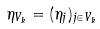<formula> <loc_0><loc_0><loc_500><loc_500>\eta _ { V _ { k } } = ( \eta _ { j } ) _ { j \in V _ { k } }</formula> 